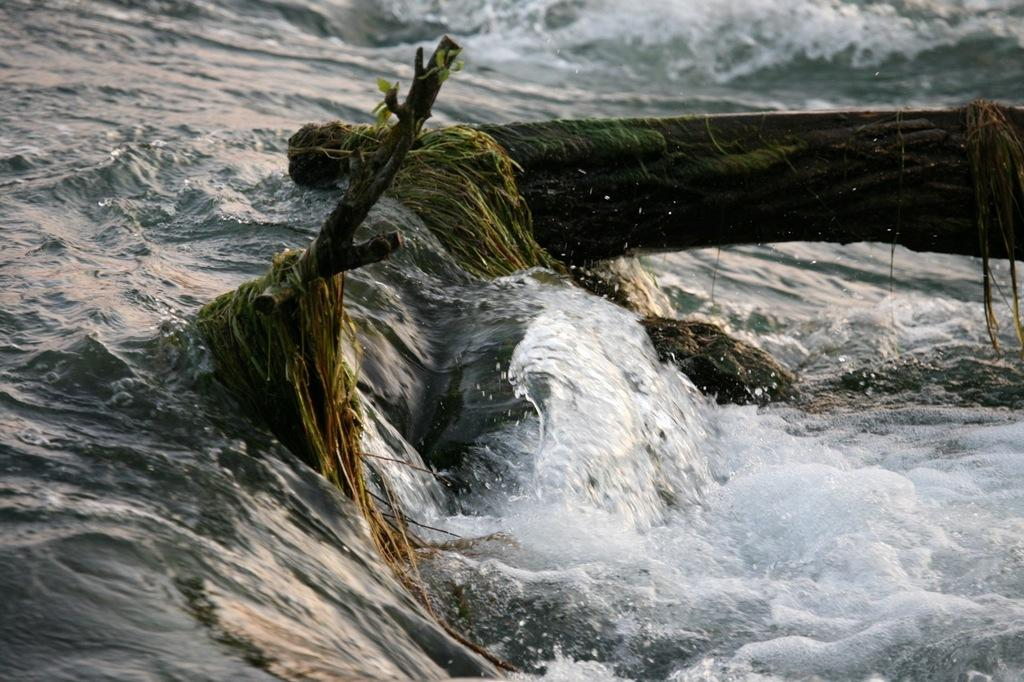What type of vegetation is visible in the image? There is grass in the image. What else can be seen in the image besides the grass? There are branches in the image. Where are the grass and branches located? The grass and branches are in the water. What type of angle is the grass forming with the branches in the image? There is no specific angle mentioned or visible in the image; the grass and branches are simply in the water. 